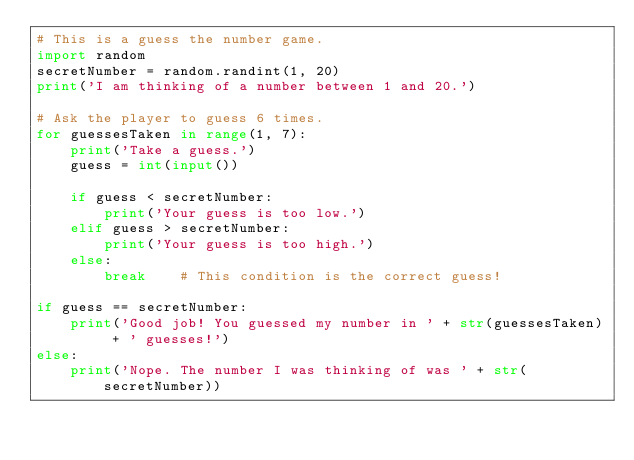<code> <loc_0><loc_0><loc_500><loc_500><_Python_># This is a guess the number game.
import random
secretNumber = random.randint(1, 20)
print('I am thinking of a number between 1 and 20.')

# Ask the player to guess 6 times.
for guessesTaken in range(1, 7):
    print('Take a guess.')
    guess = int(input())

    if guess < secretNumber:
        print('Your guess is too low.')
    elif guess > secretNumber:
        print('Your guess is too high.')
    else:
        break    # This condition is the correct guess!

if guess == secretNumber:
    print('Good job! You guessed my number in ' + str(guessesTaken) + ' guesses!')
else:
    print('Nope. The number I was thinking of was ' + str(secretNumber))</code> 